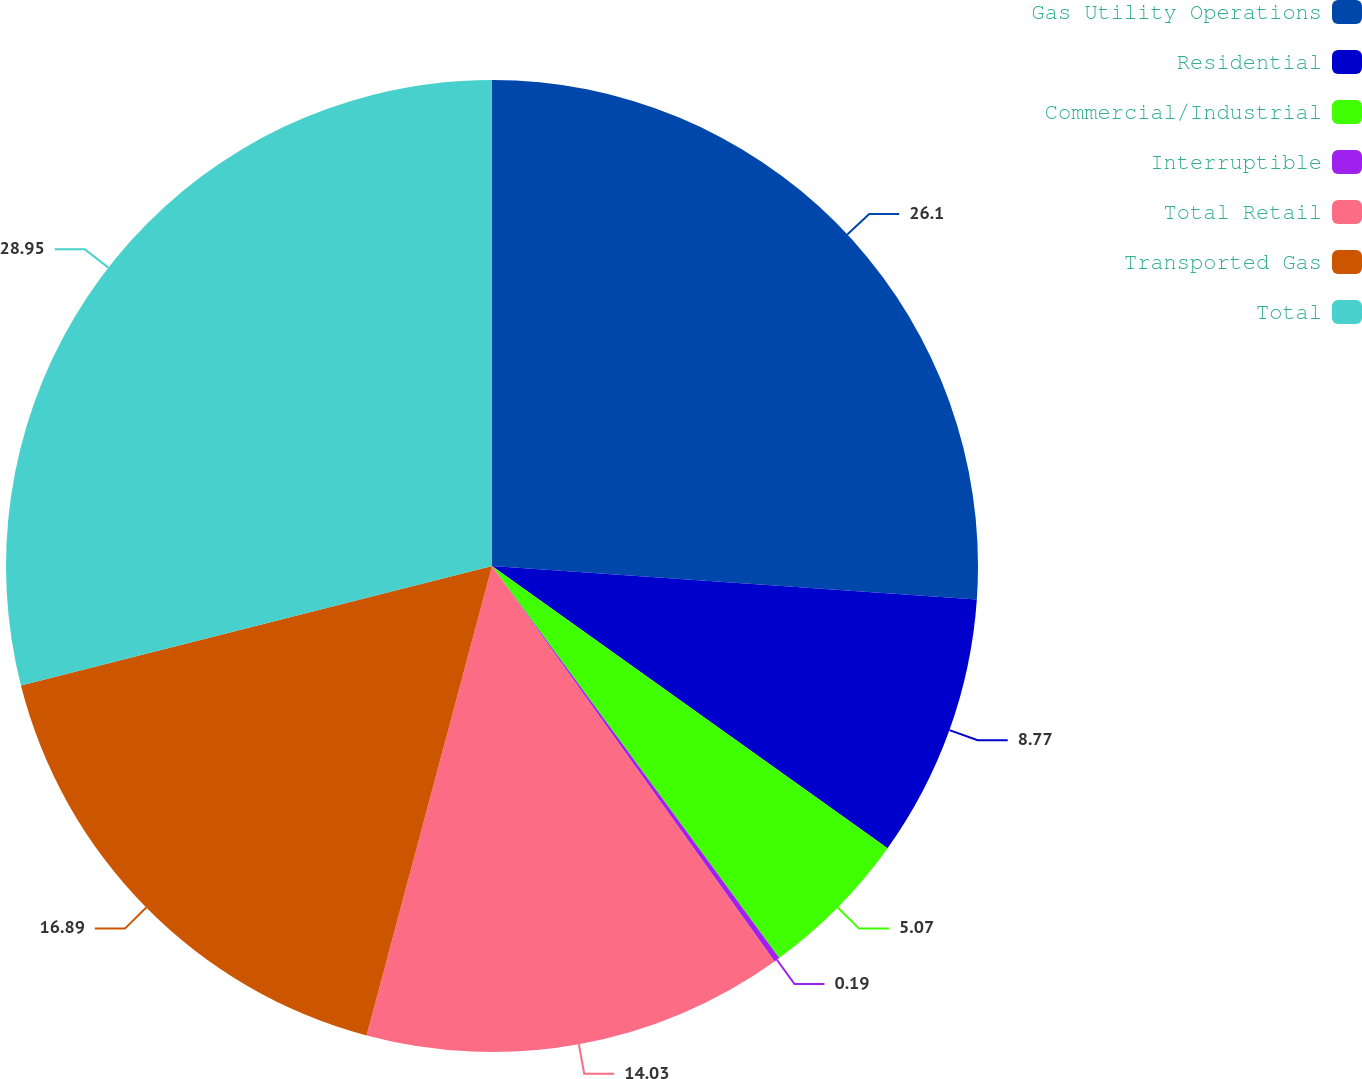Convert chart to OTSL. <chart><loc_0><loc_0><loc_500><loc_500><pie_chart><fcel>Gas Utility Operations<fcel>Residential<fcel>Commercial/Industrial<fcel>Interruptible<fcel>Total Retail<fcel>Transported Gas<fcel>Total<nl><fcel>26.1%<fcel>8.77%<fcel>5.07%<fcel>0.19%<fcel>14.03%<fcel>16.89%<fcel>28.96%<nl></chart> 